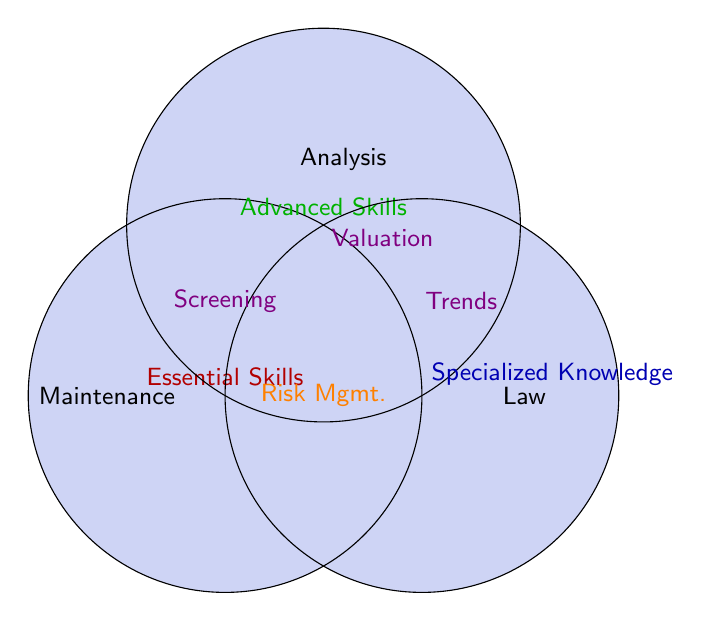What skills are in the intersection of all three sets? The skills that lie in the overlap of all three circles (red, green, and blue) are labeled as 'Risk Mgmt.' in the figure.
Answer: Risk management Which set focuses on 'Maintenance'? The label 'Maintenance' is placed within the red circle, which means it belongs to Essential Skills.
Answer: Essential Skills What skills are in the intersection of Essential Skills and Advanced Skills but not in Specialized Knowledge? The red and green overlapping area outside the blue circle contains 'Screening'.
Answer: Tenant screening How many skills are unique to Specialized Knowledge? The blue circle's individual area lists 'Real estate law,' 'Market trend analysis,' and 'Long-term wealth building,' totaling three skills.
Answer: Three Which section represents the intersection between Advanced Skills and Specialized Knowledge? The intersection between the green and blue circles contains 'Valuation'.
Answer: Property valuation What does the red circle represent? The text within the red circle labeled 'Maintenance' indicates that it represents Essential Skills.
Answer: Essential Skills Which group includes 'Law'? The single label 'Law' is placed in the blue circle, corresponding to Specialized Knowledge.
Answer: Specialized Knowledge Which circles overlap to indicate 'Trends'? 'Trends' is placed in the overlapping area between Advanced Skills (green) and Specialized Knowledge (blue).
Answer: Advanced Skills and Specialized Knowledge What skills appear only within the Advanced Skills set? The skills 'Investment strategies,' 'Portfolio diversification,' and 'Risk management' are solely within the green circle.
Answer: Investment strategies, Portfolio diversification, Risk management What set does not include 'Screening'? 'Screening' is present in the overlap of Essential Skills and Advanced Skills, which means it is not part of the Specialized Knowledge (blue circle).
Answer: Specialized Knowledge 